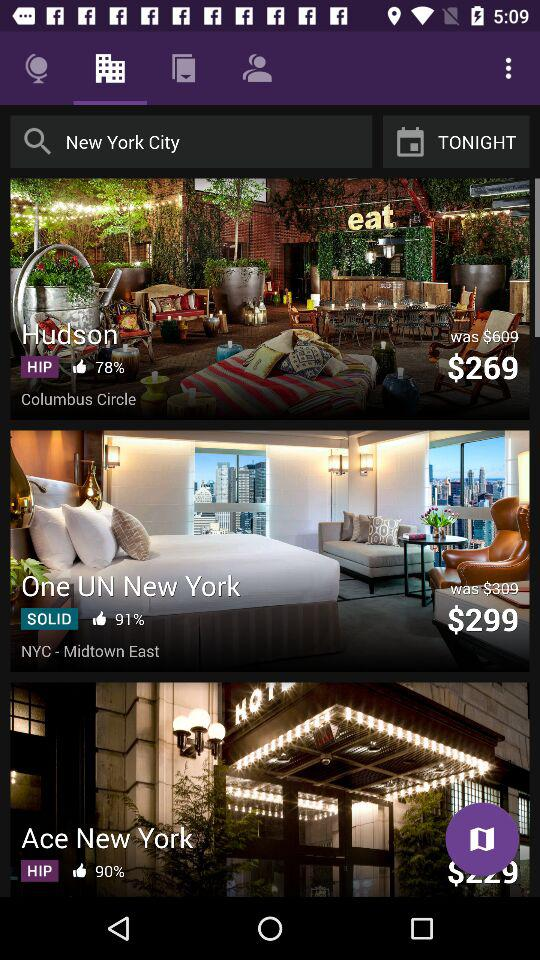What is the percentage of likes for "Hudson" Hotel? The percentage of likes is 78. 